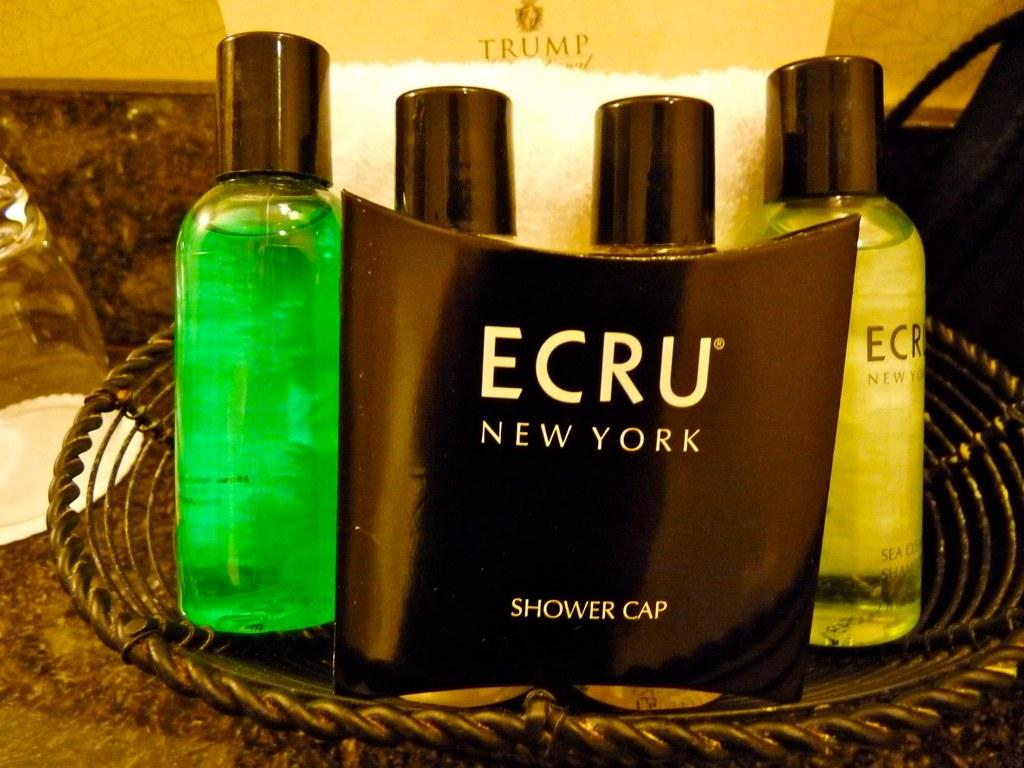<image>
Describe the image concisely. A basket of hotel amenity toiletries which are Ecru brand. 